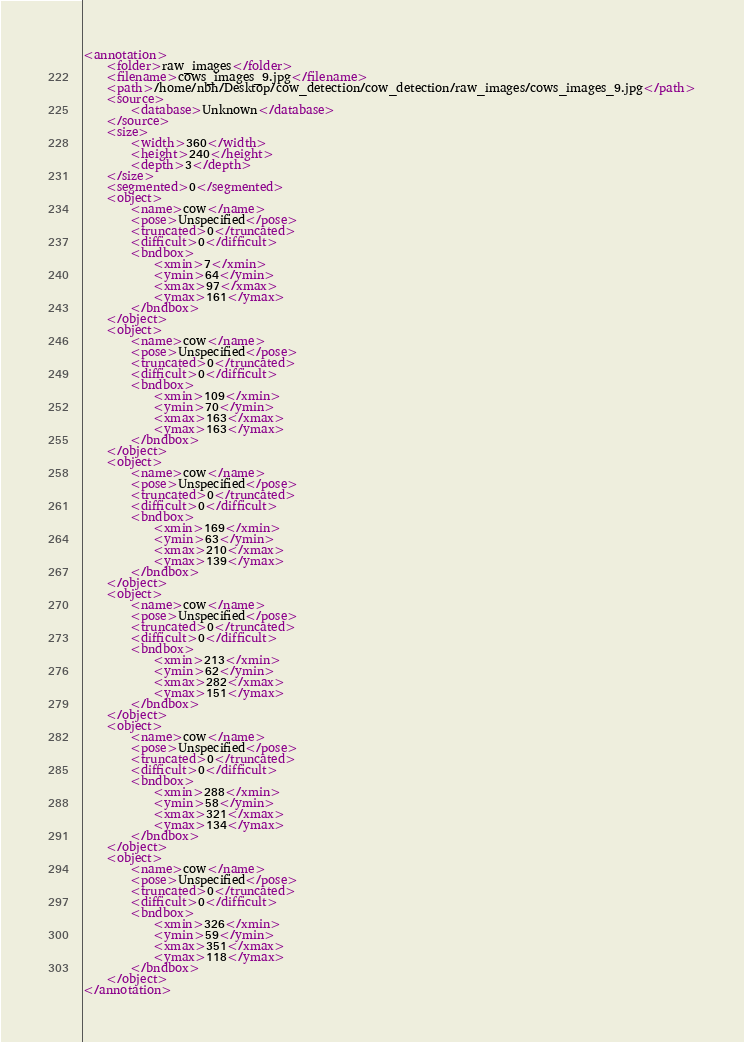<code> <loc_0><loc_0><loc_500><loc_500><_XML_><annotation>
	<folder>raw_images</folder>
	<filename>cows_images_9.jpg</filename>
	<path>/home/nbh/Desktop/cow_detection/cow_detection/raw_images/cows_images_9.jpg</path>
	<source>
		<database>Unknown</database>
	</source>
	<size>
		<width>360</width>
		<height>240</height>
		<depth>3</depth>
	</size>
	<segmented>0</segmented>
	<object>
		<name>cow</name>
		<pose>Unspecified</pose>
		<truncated>0</truncated>
		<difficult>0</difficult>
		<bndbox>
			<xmin>7</xmin>
			<ymin>64</ymin>
			<xmax>97</xmax>
			<ymax>161</ymax>
		</bndbox>
	</object>
	<object>
		<name>cow</name>
		<pose>Unspecified</pose>
		<truncated>0</truncated>
		<difficult>0</difficult>
		<bndbox>
			<xmin>109</xmin>
			<ymin>70</ymin>
			<xmax>163</xmax>
			<ymax>163</ymax>
		</bndbox>
	</object>
	<object>
		<name>cow</name>
		<pose>Unspecified</pose>
		<truncated>0</truncated>
		<difficult>0</difficult>
		<bndbox>
			<xmin>169</xmin>
			<ymin>63</ymin>
			<xmax>210</xmax>
			<ymax>139</ymax>
		</bndbox>
	</object>
	<object>
		<name>cow</name>
		<pose>Unspecified</pose>
		<truncated>0</truncated>
		<difficult>0</difficult>
		<bndbox>
			<xmin>213</xmin>
			<ymin>62</ymin>
			<xmax>282</xmax>
			<ymax>151</ymax>
		</bndbox>
	</object>
	<object>
		<name>cow</name>
		<pose>Unspecified</pose>
		<truncated>0</truncated>
		<difficult>0</difficult>
		<bndbox>
			<xmin>288</xmin>
			<ymin>58</ymin>
			<xmax>321</xmax>
			<ymax>134</ymax>
		</bndbox>
	</object>
	<object>
		<name>cow</name>
		<pose>Unspecified</pose>
		<truncated>0</truncated>
		<difficult>0</difficult>
		<bndbox>
			<xmin>326</xmin>
			<ymin>59</ymin>
			<xmax>351</xmax>
			<ymax>118</ymax>
		</bndbox>
	</object>
</annotation>
</code> 